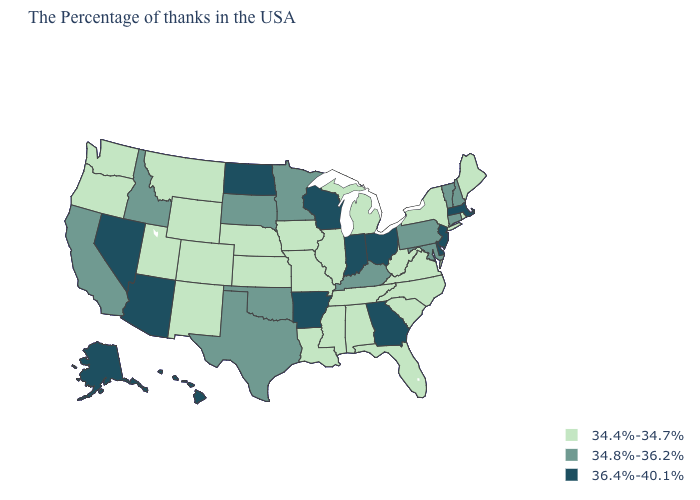Which states have the lowest value in the MidWest?
Answer briefly. Michigan, Illinois, Missouri, Iowa, Kansas, Nebraska. What is the highest value in the USA?
Keep it brief. 36.4%-40.1%. Which states have the lowest value in the USA?
Write a very short answer. Maine, Rhode Island, New York, Virginia, North Carolina, South Carolina, West Virginia, Florida, Michigan, Alabama, Tennessee, Illinois, Mississippi, Louisiana, Missouri, Iowa, Kansas, Nebraska, Wyoming, Colorado, New Mexico, Utah, Montana, Washington, Oregon. Is the legend a continuous bar?
Short answer required. No. What is the highest value in states that border South Carolina?
Short answer required. 36.4%-40.1%. Is the legend a continuous bar?
Quick response, please. No. Is the legend a continuous bar?
Write a very short answer. No. What is the value of New Jersey?
Be succinct. 36.4%-40.1%. What is the lowest value in states that border South Dakota?
Keep it brief. 34.4%-34.7%. Does Oklahoma have a higher value than Colorado?
Write a very short answer. Yes. What is the value of South Dakota?
Concise answer only. 34.8%-36.2%. Name the states that have a value in the range 36.4%-40.1%?
Quick response, please. Massachusetts, New Jersey, Delaware, Ohio, Georgia, Indiana, Wisconsin, Arkansas, North Dakota, Arizona, Nevada, Alaska, Hawaii. Among the states that border North Carolina , does Virginia have the highest value?
Be succinct. No. What is the value of Kentucky?
Short answer required. 34.8%-36.2%. 